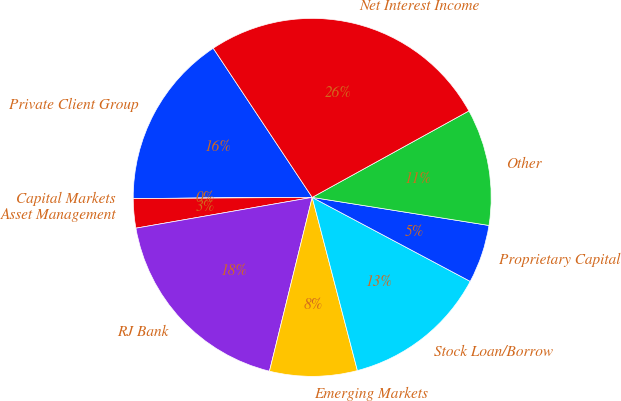Convert chart. <chart><loc_0><loc_0><loc_500><loc_500><pie_chart><fcel>Private Client Group<fcel>Capital Markets<fcel>Asset Management<fcel>RJ Bank<fcel>Emerging Markets<fcel>Stock Loan/Borrow<fcel>Proprietary Capital<fcel>Other<fcel>Net Interest Income<nl><fcel>15.78%<fcel>0.01%<fcel>2.64%<fcel>18.41%<fcel>7.9%<fcel>13.16%<fcel>5.27%<fcel>10.53%<fcel>26.3%<nl></chart> 